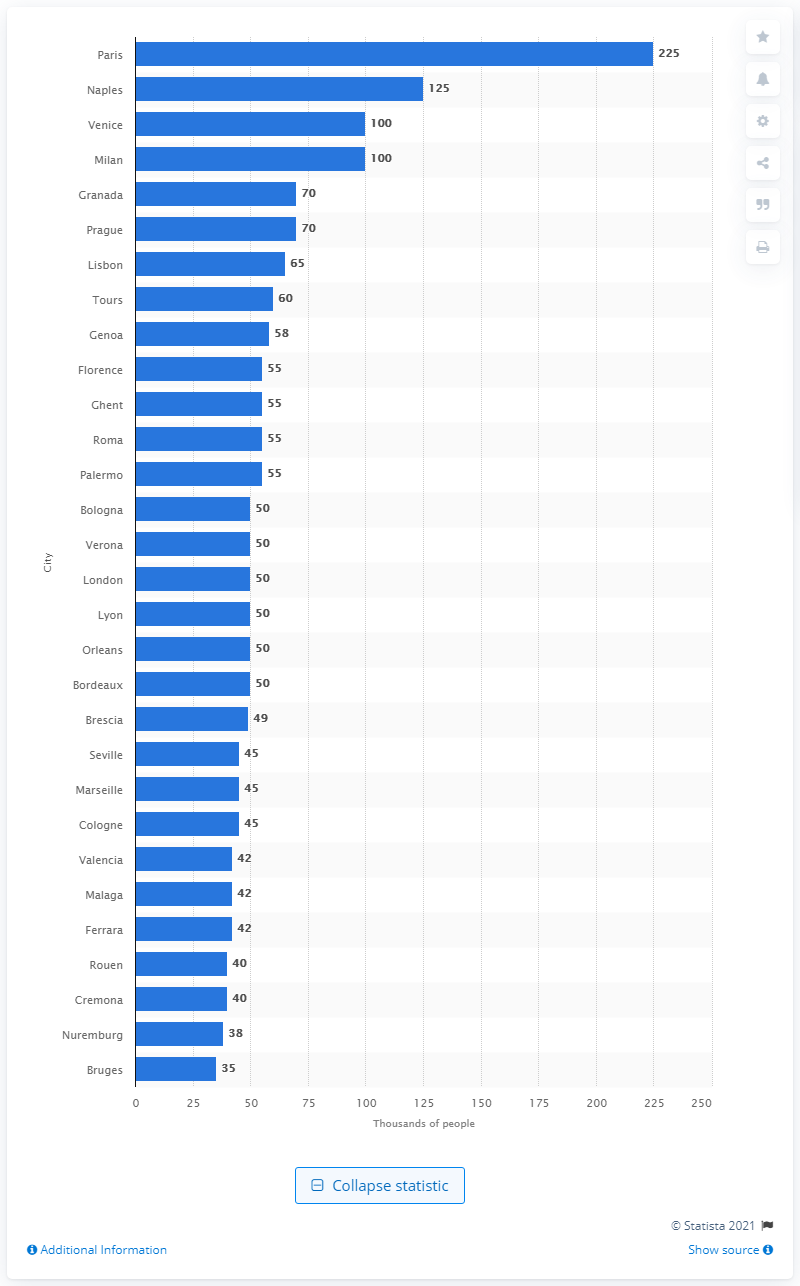Specify some key components in this picture. In 1500, Naples was the second largest city in the world. 